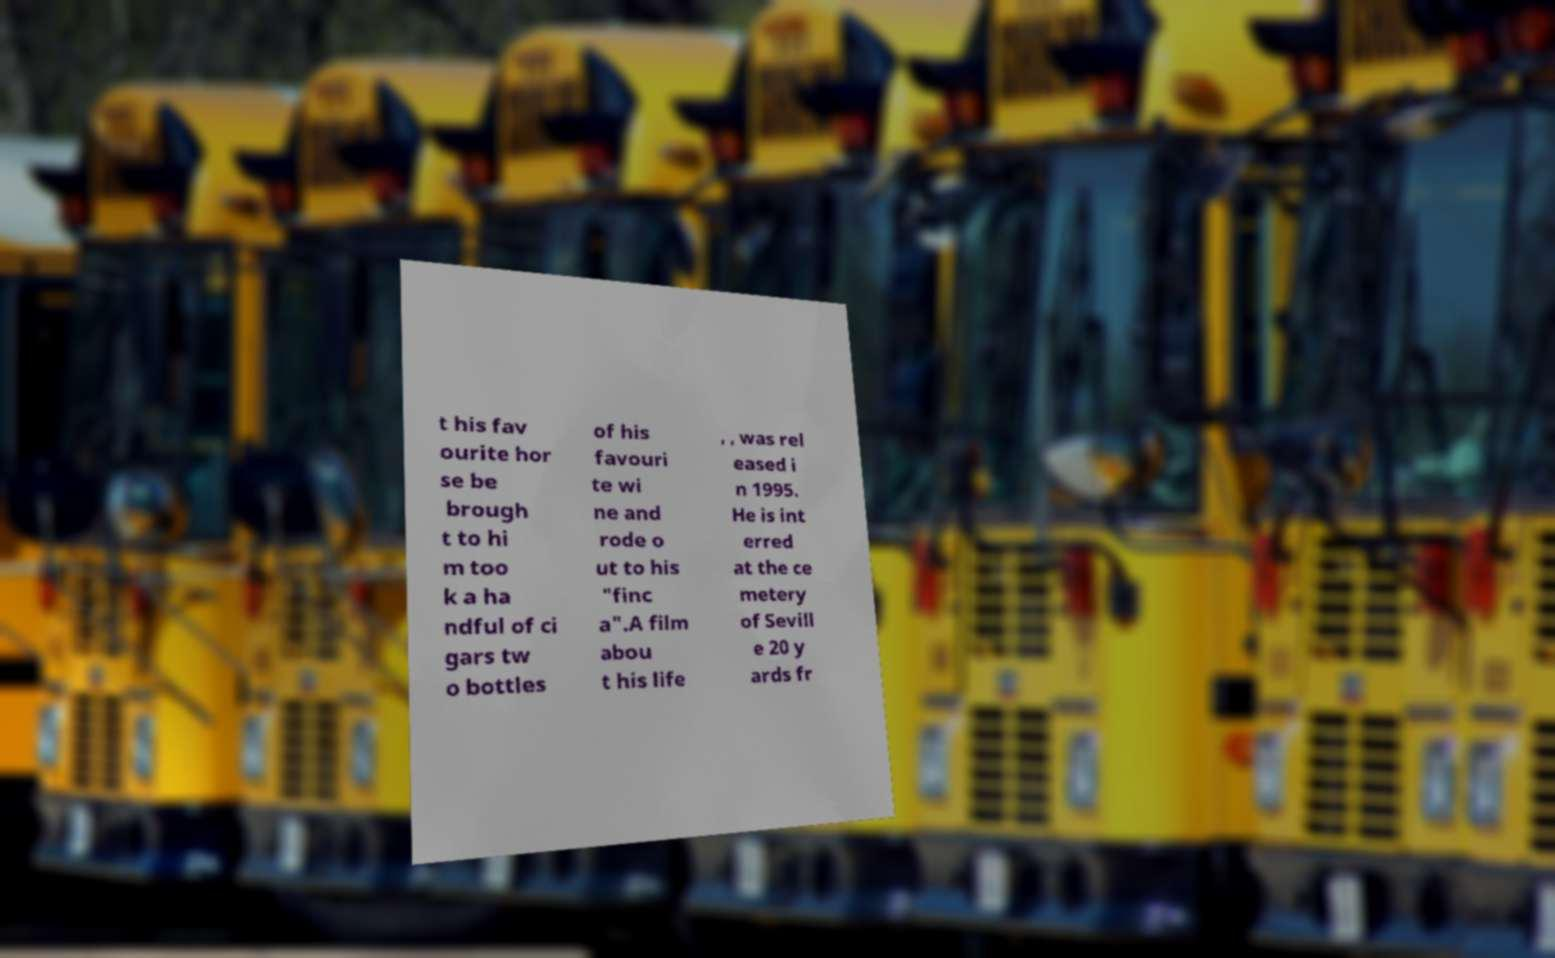What messages or text are displayed in this image? I need them in a readable, typed format. t his fav ourite hor se be brough t to hi m too k a ha ndful of ci gars tw o bottles of his favouri te wi ne and rode o ut to his "finc a".A film abou t his life , , was rel eased i n 1995. He is int erred at the ce metery of Sevill e 20 y ards fr 